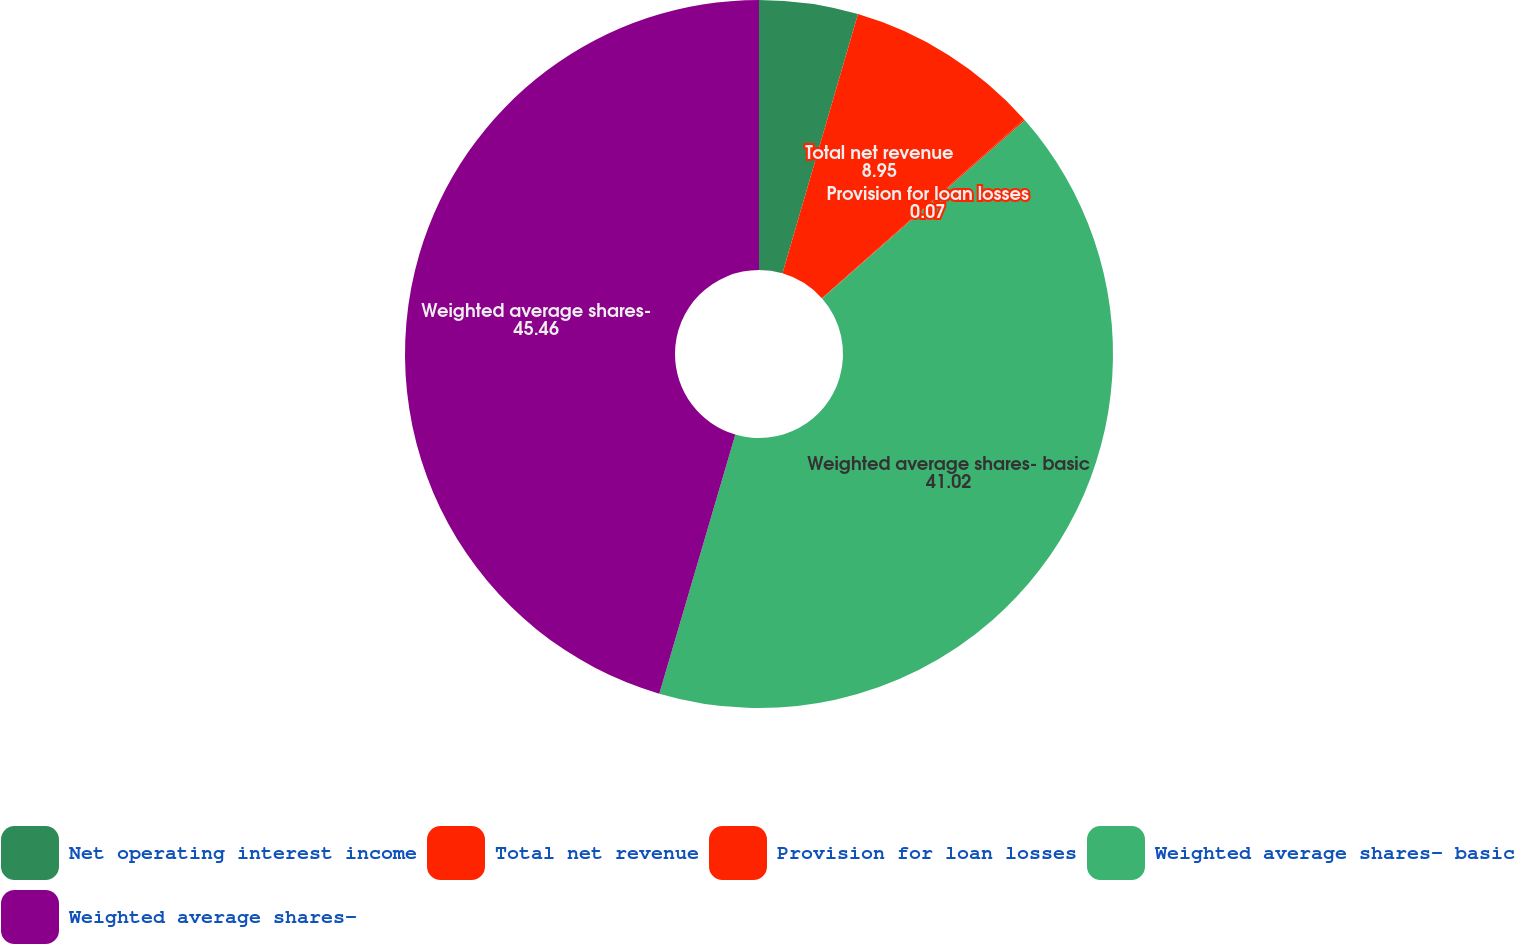Convert chart. <chart><loc_0><loc_0><loc_500><loc_500><pie_chart><fcel>Net operating interest income<fcel>Total net revenue<fcel>Provision for loan losses<fcel>Weighted average shares- basic<fcel>Weighted average shares-<nl><fcel>4.51%<fcel>8.95%<fcel>0.07%<fcel>41.02%<fcel>45.46%<nl></chart> 